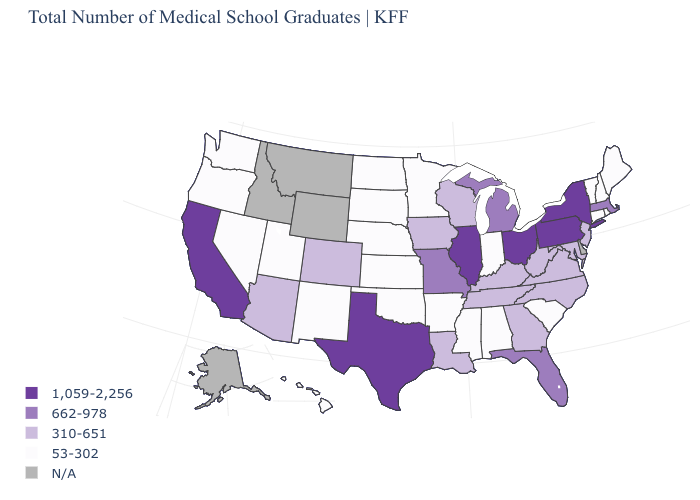What is the value of North Carolina?
Be succinct. 310-651. What is the value of Utah?
Keep it brief. 53-302. What is the value of Idaho?
Answer briefly. N/A. Name the states that have a value in the range 53-302?
Quick response, please. Alabama, Arkansas, Connecticut, Hawaii, Indiana, Kansas, Maine, Minnesota, Mississippi, Nebraska, Nevada, New Hampshire, New Mexico, North Dakota, Oklahoma, Oregon, Rhode Island, South Carolina, South Dakota, Utah, Vermont, Washington. Among the states that border West Virginia , does Kentucky have the highest value?
Give a very brief answer. No. How many symbols are there in the legend?
Answer briefly. 5. Among the states that border Maine , which have the highest value?
Write a very short answer. New Hampshire. What is the value of Minnesota?
Concise answer only. 53-302. What is the lowest value in states that border Utah?
Answer briefly. 53-302. What is the lowest value in states that border Wyoming?
Quick response, please. 53-302. Which states hav the highest value in the West?
Give a very brief answer. California. What is the lowest value in the USA?
Short answer required. 53-302. Does the first symbol in the legend represent the smallest category?
Concise answer only. No. Does the map have missing data?
Quick response, please. Yes. 